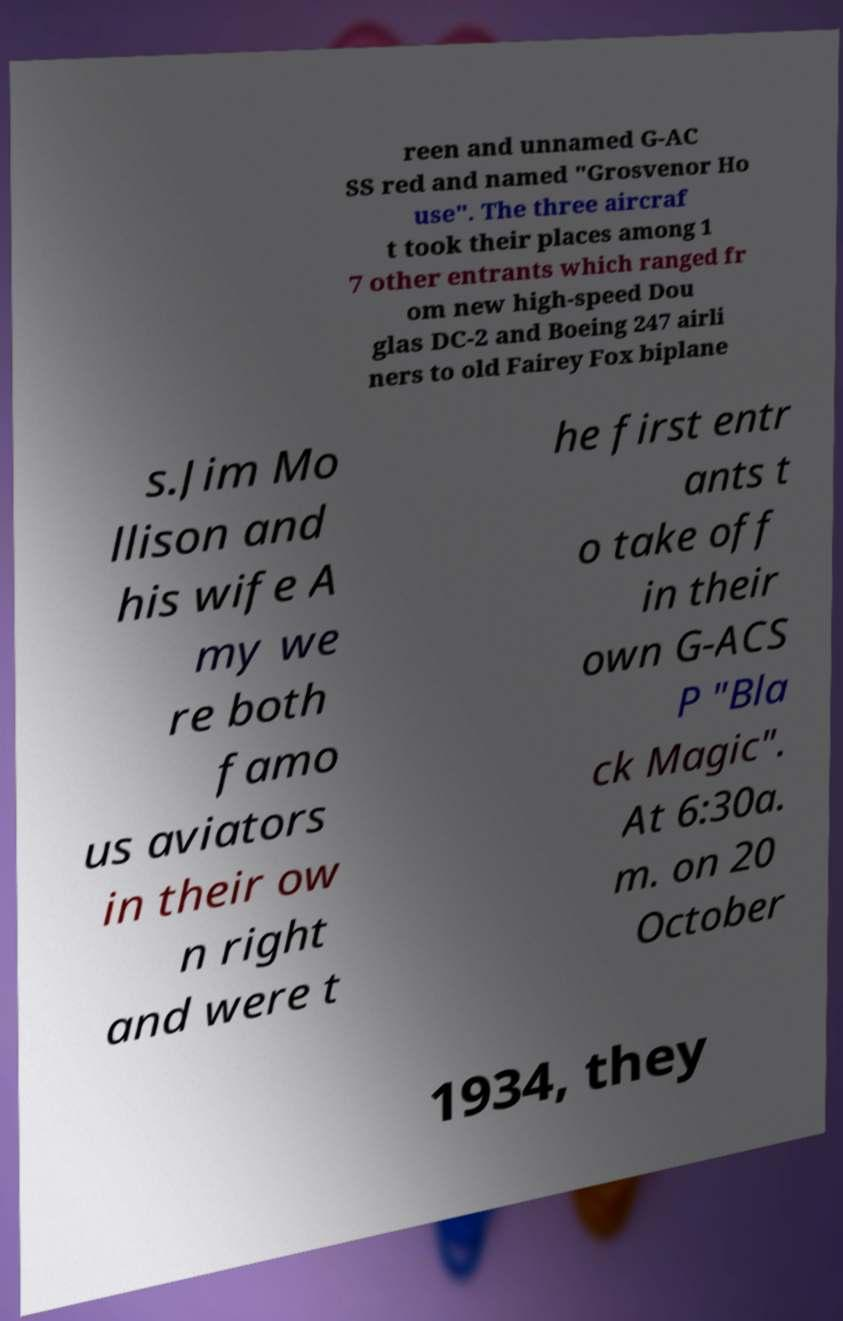I need the written content from this picture converted into text. Can you do that? reen and unnamed G-AC SS red and named "Grosvenor Ho use". The three aircraf t took their places among 1 7 other entrants which ranged fr om new high-speed Dou glas DC-2 and Boeing 247 airli ners to old Fairey Fox biplane s.Jim Mo llison and his wife A my we re both famo us aviators in their ow n right and were t he first entr ants t o take off in their own G-ACS P "Bla ck Magic". At 6:30a. m. on 20 October 1934, they 